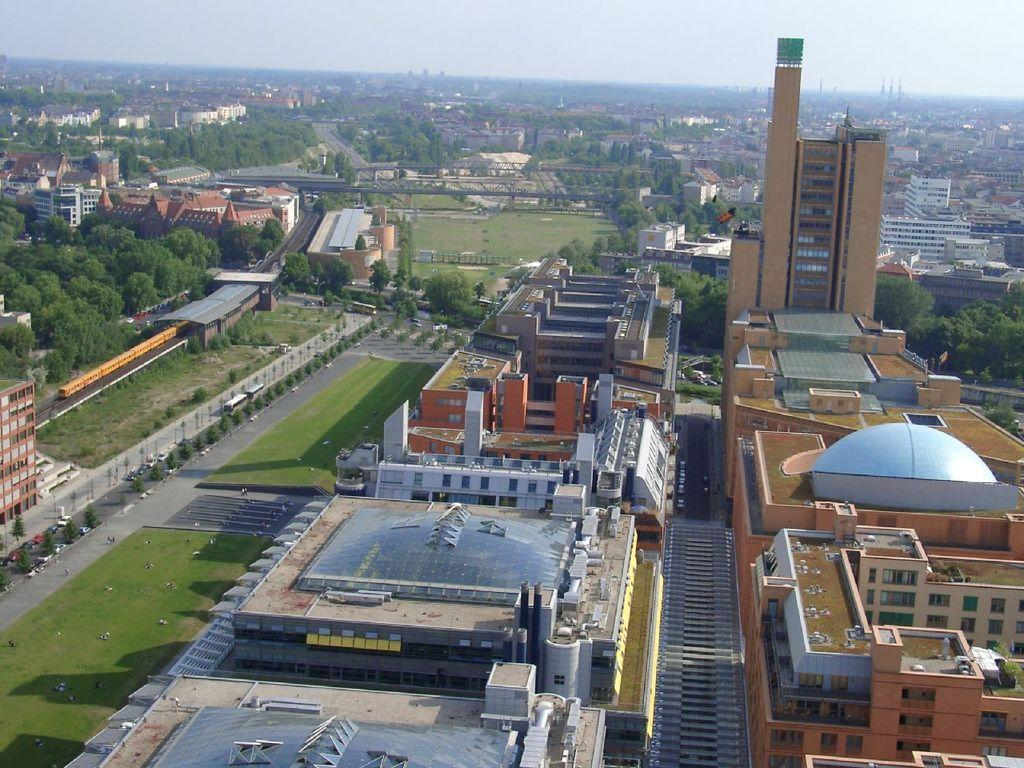What type of structures can be seen in the image? There are buildings in the image. What type of vegetation is present in the image? There are trees and grass in the image. What else can be seen in the image besides buildings and vegetation? There are vehicles in the image. What is visible at the top of the image? The sky is visible at the top of the image. Where is the bucket of juice located in the image? There is no bucket or juice present in the image. What is the dad doing in the image? There is no dad present in the image. 